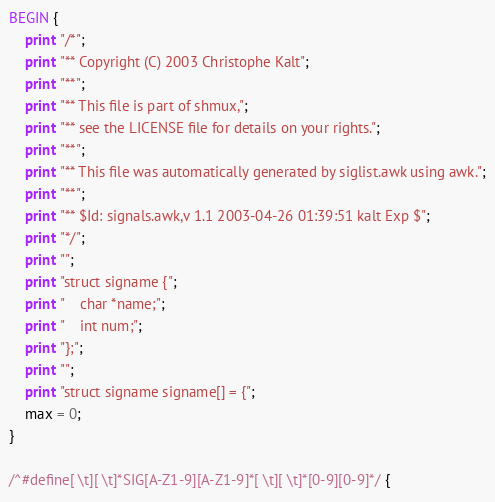<code> <loc_0><loc_0><loc_500><loc_500><_Awk_>BEGIN {
    print "/*";
    print "** Copyright (C) 2003 Christophe Kalt";
    print "**";
    print "** This file is part of shmux,";
    print "** see the LICENSE file for details on your rights.";
    print "**";
    print "** This file was automatically generated by siglist.awk using awk.";
    print "**";
    print "** $Id: signals.awk,v 1.1 2003-04-26 01:39:51 kalt Exp $";
    print "*/";
    print "";
    print "struct signame {";
    print "    char *name;";
    print "    int num;";
    print "};";
    print "";
    print "struct signame signame[] = {";
    max = 0;
}

/^#define[ \t][ \t]*SIG[A-Z1-9][A-Z1-9]*[ \t][ \t]*[0-9][0-9]*/ {</code> 